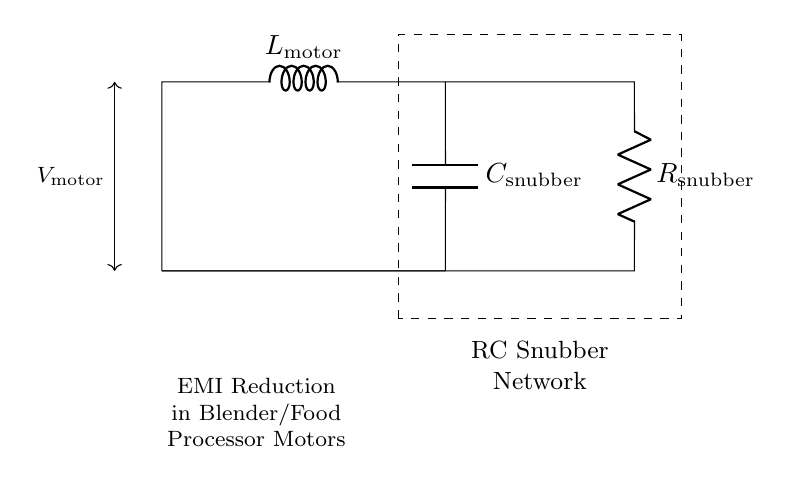What does the snubber circuit consist of? The snubber circuit consists of a resistor and a capacitor, indicated in the diagram. The labels show the resistor as R_snubber and the capacitor as C_snubber.
Answer: resistor and capacitor What is the purpose of the snubber circuit in this diagram? The purpose of the snubber circuit is to reduce electromagnetic interference (EMI) generated by the motor during operation, as noted in the label.
Answer: EMI reduction What type of circuit is shown in the diagram? The diagram represents an RC snubber circuit, explicitly made up of resistor and capacitor components connected to a motor.
Answer: RC snubber circuit What is the role of the inductor in this circuit? The inductor, labeled as L_motor, helps to smooth out current fluctuations and manage the inductive load from the motor, which is crucial for minimizing EMI.
Answer: smoothing current fluctuations Which component dissipates energy in this circuit? The resistor, labeled as R_snubber, dissipates energy as heat, which is inherent to its function in the snubber circuit.
Answer: resistor What is the connection configuration of the snubber components? The components are connected in parallel with respect to the motor, as indicated by their placement alongside the L_motor.
Answer: parallel connection How does the capacitor affect the overall circuit performance? The capacitor, labeled as C_snubber, stores and releases energy, which helps to dampen voltage spikes and maintain a steady operation during motor switching.
Answer: dampens voltage spikes 